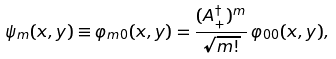<formula> <loc_0><loc_0><loc_500><loc_500>\psi _ { m } ( x , y ) \equiv \varphi _ { m 0 } ( x , y ) = \frac { ( A _ { + } ^ { \dagger } ) ^ { m } } { \sqrt { m ! } } \, \varphi _ { 0 0 } ( x , y ) ,</formula> 